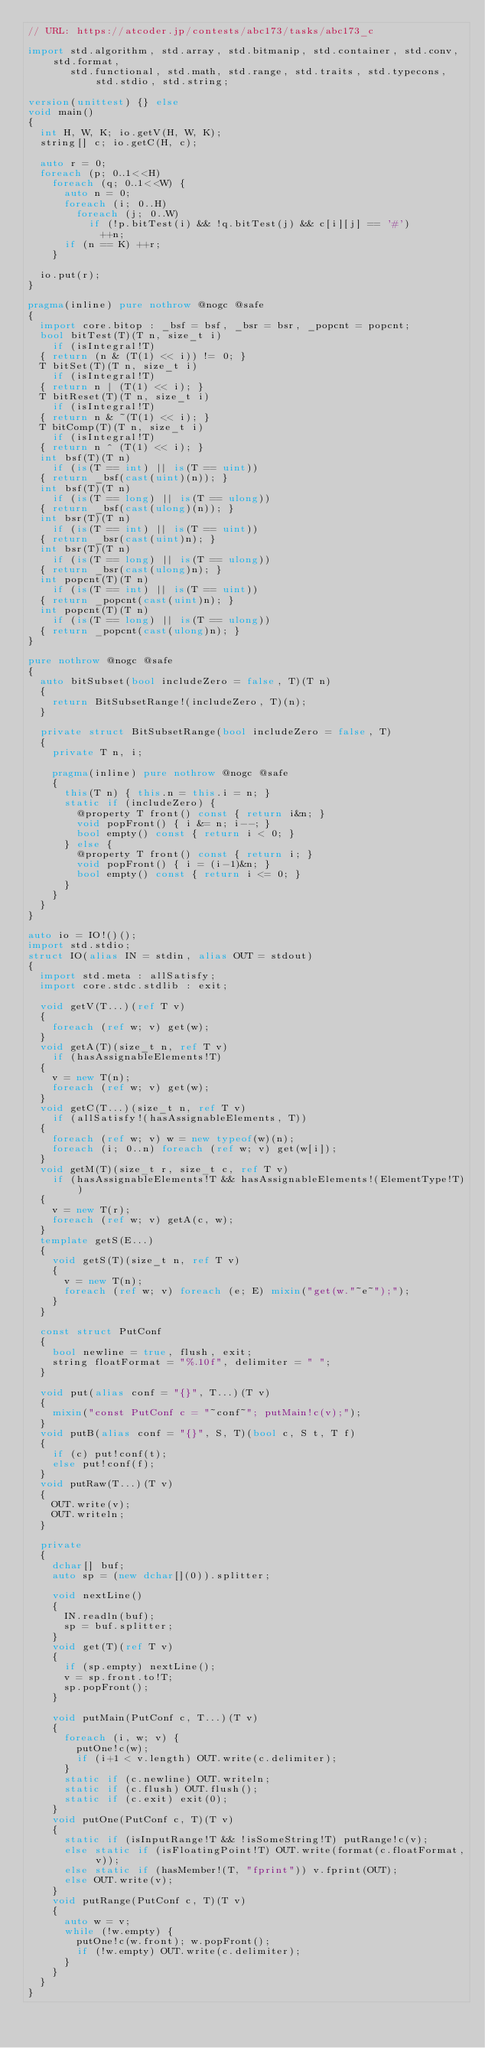Convert code to text. <code><loc_0><loc_0><loc_500><loc_500><_D_>// URL: https://atcoder.jp/contests/abc173/tasks/abc173_c

import std.algorithm, std.array, std.bitmanip, std.container, std.conv, std.format,
       std.functional, std.math, std.range, std.traits, std.typecons, std.stdio, std.string;

version(unittest) {} else
void main()
{
  int H, W, K; io.getV(H, W, K);
  string[] c; io.getC(H, c);

  auto r = 0;
  foreach (p; 0..1<<H)
    foreach (q; 0..1<<W) {
      auto n = 0;
      foreach (i; 0..H)
        foreach (j; 0..W)
          if (!p.bitTest(i) && !q.bitTest(j) && c[i][j] == '#')
            ++n;
      if (n == K) ++r;
    }

  io.put(r);
}

pragma(inline) pure nothrow @nogc @safe
{
  import core.bitop : _bsf = bsf, _bsr = bsr, _popcnt = popcnt;
  bool bitTest(T)(T n, size_t i)
    if (isIntegral!T)
  { return (n & (T(1) << i)) != 0; }
  T bitSet(T)(T n, size_t i)
    if (isIntegral!T)
  { return n | (T(1) << i); }
  T bitReset(T)(T n, size_t i)
    if (isIntegral!T)
  { return n & ~(T(1) << i); }
  T bitComp(T)(T n, size_t i)
    if (isIntegral!T)
  { return n ^ (T(1) << i); }
  int bsf(T)(T n)
    if (is(T == int) || is(T == uint))
  { return _bsf(cast(uint)(n)); }
  int bsf(T)(T n)
    if (is(T == long) || is(T == ulong))
  { return _bsf(cast(ulong)(n)); }
  int bsr(T)(T n)
    if (is(T == int) || is(T == uint))
  { return _bsr(cast(uint)n); }
  int bsr(T)(T n)
    if (is(T == long) || is(T == ulong))
  { return _bsr(cast(ulong)n); }
  int popcnt(T)(T n)
    if (is(T == int) || is(T == uint))
  { return _popcnt(cast(uint)n); }
  int popcnt(T)(T n)
    if (is(T == long) || is(T == ulong))
  { return _popcnt(cast(ulong)n); }
}

pure nothrow @nogc @safe
{
  auto bitSubset(bool includeZero = false, T)(T n)
  {
    return BitSubsetRange!(includeZero, T)(n);
  }

  private struct BitSubsetRange(bool includeZero = false, T)
  {
    private T n, i;

    pragma(inline) pure nothrow @nogc @safe
    {
      this(T n) { this.n = this.i = n; }
      static if (includeZero) {
        @property T front() const { return i&n; }
        void popFront() { i &= n; i--; }
        bool empty() const { return i < 0; }
      } else {
        @property T front() const { return i; }
        void popFront() { i = (i-1)&n; }
        bool empty() const { return i <= 0; }
      }
    }
  }
}

auto io = IO!()();
import std.stdio;
struct IO(alias IN = stdin, alias OUT = stdout)
{
  import std.meta : allSatisfy;
  import core.stdc.stdlib : exit;

  void getV(T...)(ref T v)
  {
    foreach (ref w; v) get(w);
  }
  void getA(T)(size_t n, ref T v)
    if (hasAssignableElements!T)
  {
    v = new T(n);
    foreach (ref w; v) get(w);
  }
  void getC(T...)(size_t n, ref T v)
    if (allSatisfy!(hasAssignableElements, T))
  {
    foreach (ref w; v) w = new typeof(w)(n);
    foreach (i; 0..n) foreach (ref w; v) get(w[i]);
  }
  void getM(T)(size_t r, size_t c, ref T v)
    if (hasAssignableElements!T && hasAssignableElements!(ElementType!T))
  {
    v = new T(r);
    foreach (ref w; v) getA(c, w);
  }
  template getS(E...)
  {
    void getS(T)(size_t n, ref T v)
    {
      v = new T(n);
      foreach (ref w; v) foreach (e; E) mixin("get(w."~e~");");
    }
  }

  const struct PutConf
  {
    bool newline = true, flush, exit;
    string floatFormat = "%.10f", delimiter = " ";
  }

  void put(alias conf = "{}", T...)(T v)
  {
    mixin("const PutConf c = "~conf~"; putMain!c(v);");
  }
  void putB(alias conf = "{}", S, T)(bool c, S t, T f)
  {
    if (c) put!conf(t);
    else put!conf(f);
  }
  void putRaw(T...)(T v)
  {
    OUT.write(v);
    OUT.writeln;
  }

  private
  {
    dchar[] buf;
    auto sp = (new dchar[](0)).splitter;

    void nextLine()
    {
      IN.readln(buf);
      sp = buf.splitter;
    }
    void get(T)(ref T v)
    {
      if (sp.empty) nextLine();
      v = sp.front.to!T;
      sp.popFront();
    }

    void putMain(PutConf c, T...)(T v)
    {
      foreach (i, w; v) {
        putOne!c(w);
        if (i+1 < v.length) OUT.write(c.delimiter);
      }
      static if (c.newline) OUT.writeln;
      static if (c.flush) OUT.flush();
      static if (c.exit) exit(0);
    }
    void putOne(PutConf c, T)(T v)
    {
      static if (isInputRange!T && !isSomeString!T) putRange!c(v);
      else static if (isFloatingPoint!T) OUT.write(format(c.floatFormat, v));
      else static if (hasMember!(T, "fprint")) v.fprint(OUT);
      else OUT.write(v);
    }
    void putRange(PutConf c, T)(T v)
    {
      auto w = v;
      while (!w.empty) {
        putOne!c(w.front); w.popFront();
        if (!w.empty) OUT.write(c.delimiter);
      }
    }
  }
}
</code> 